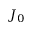<formula> <loc_0><loc_0><loc_500><loc_500>J _ { 0 }</formula> 